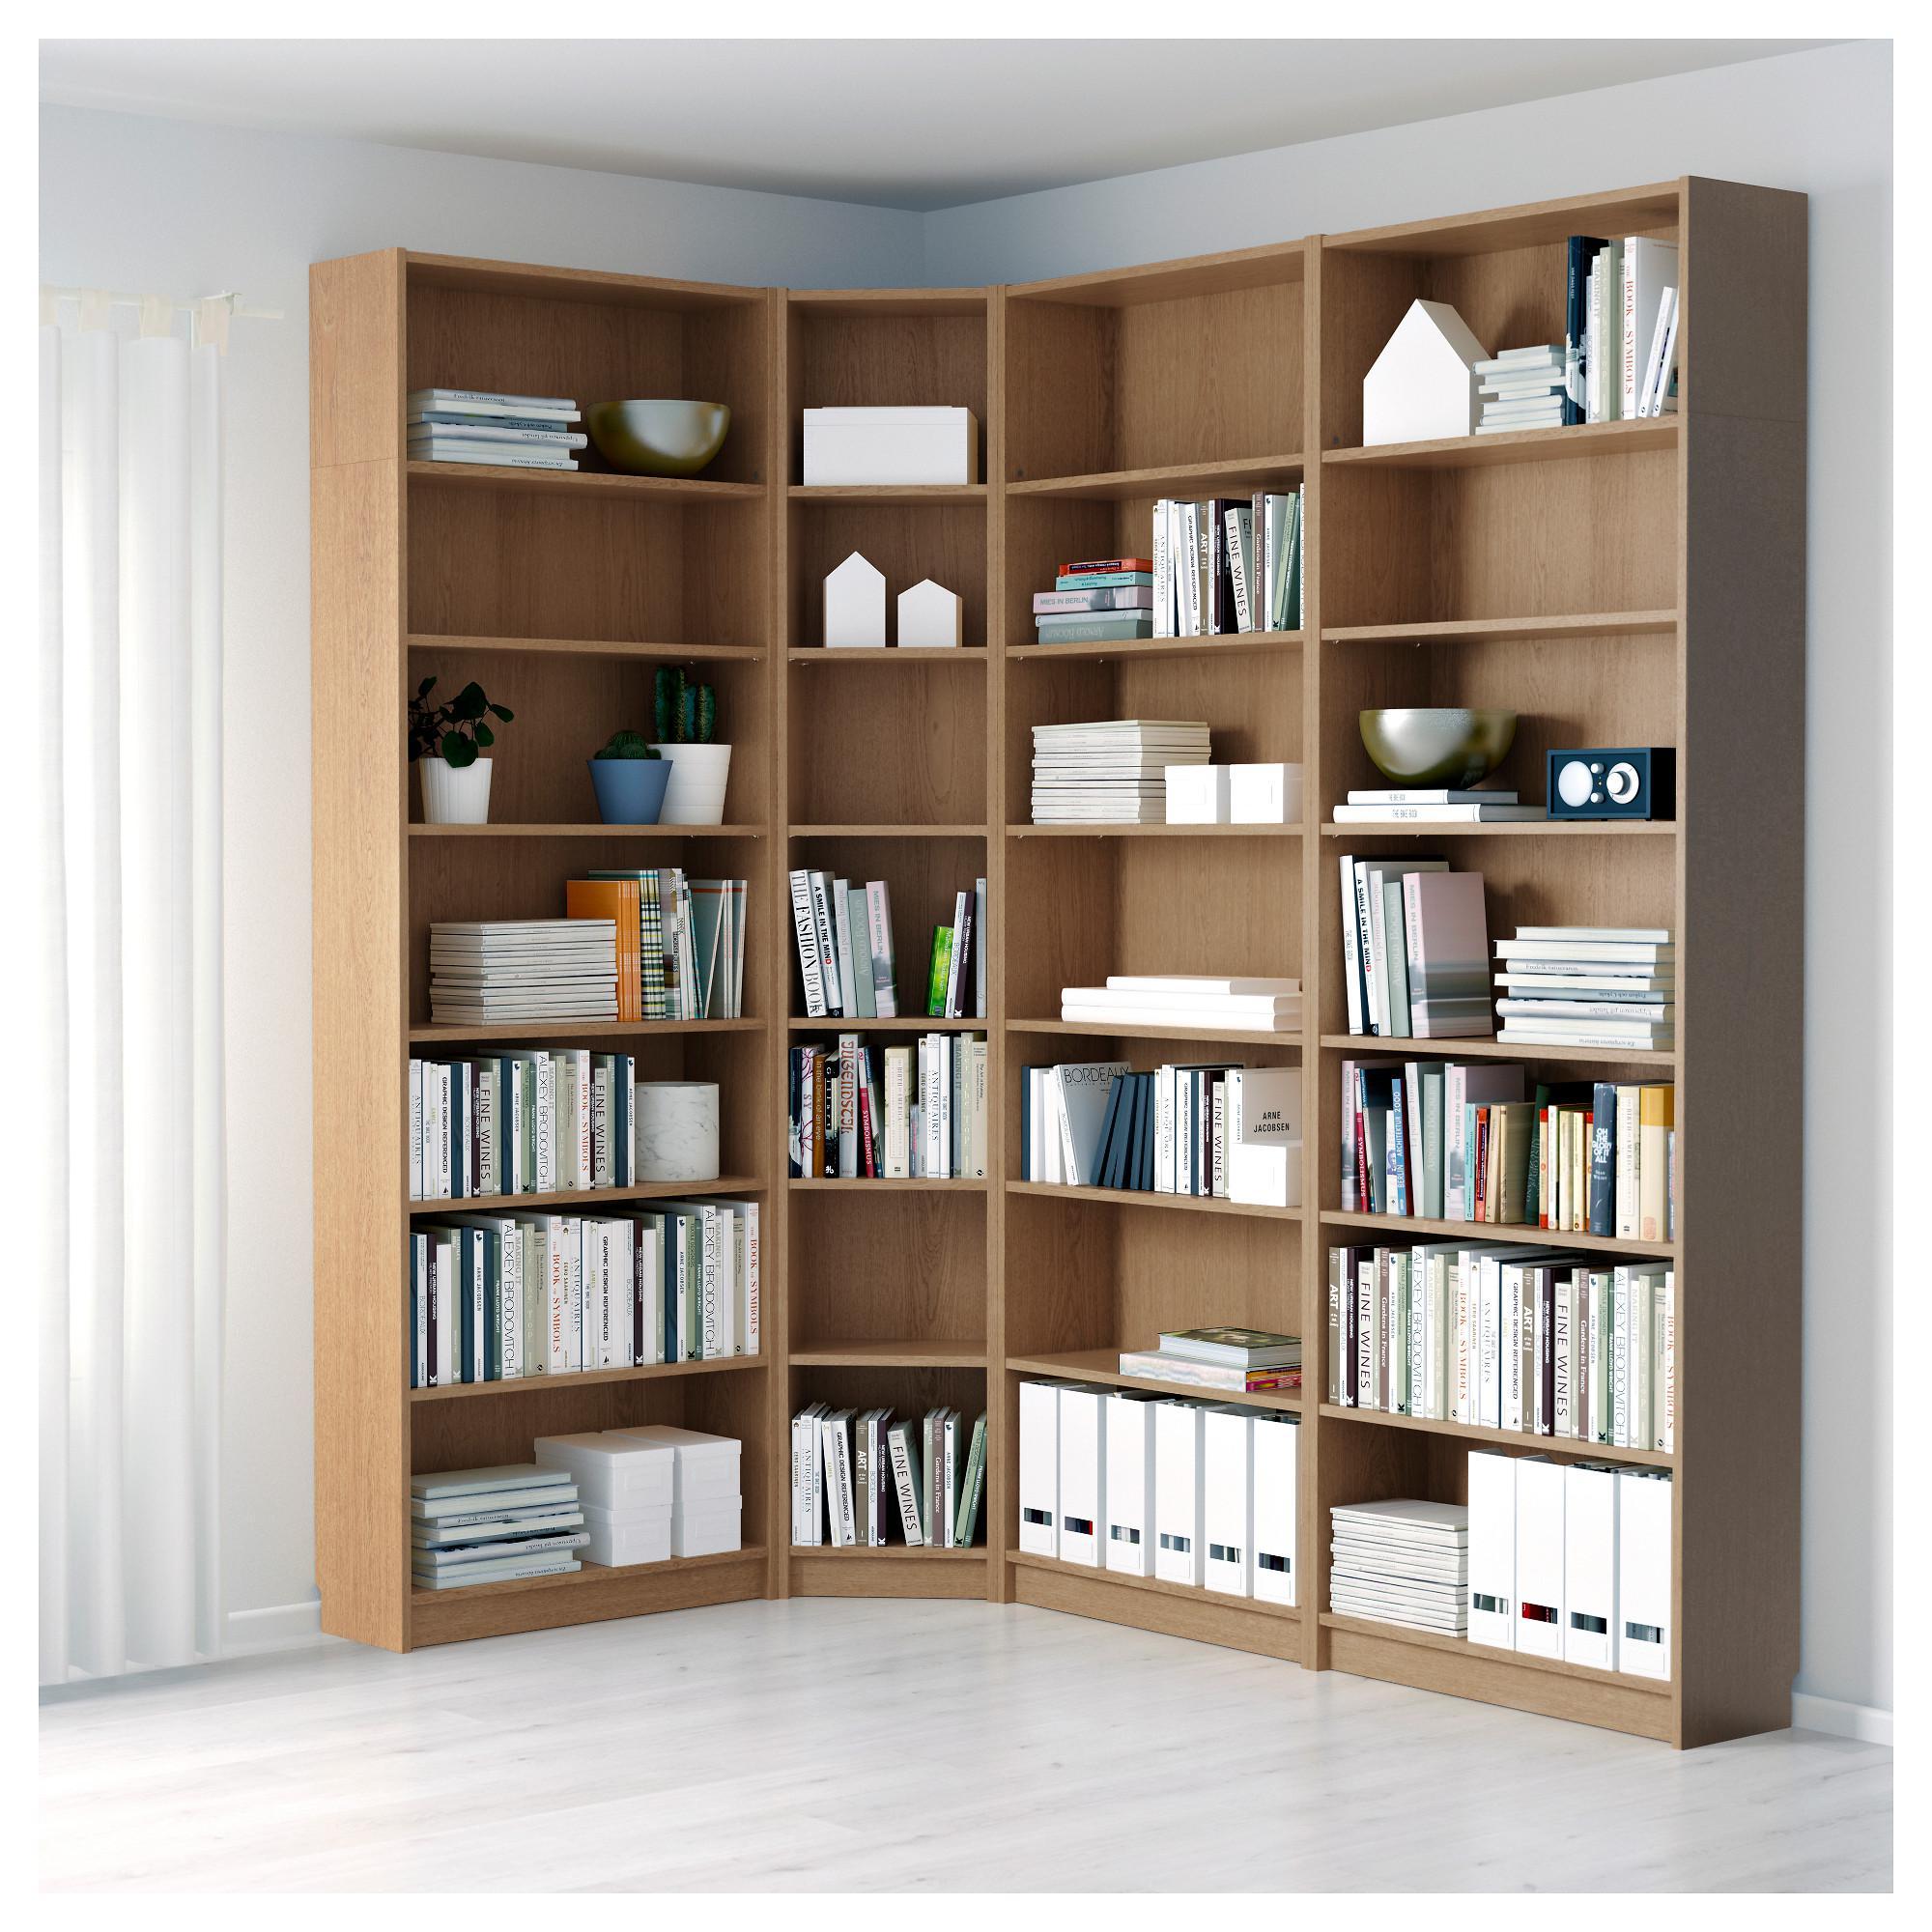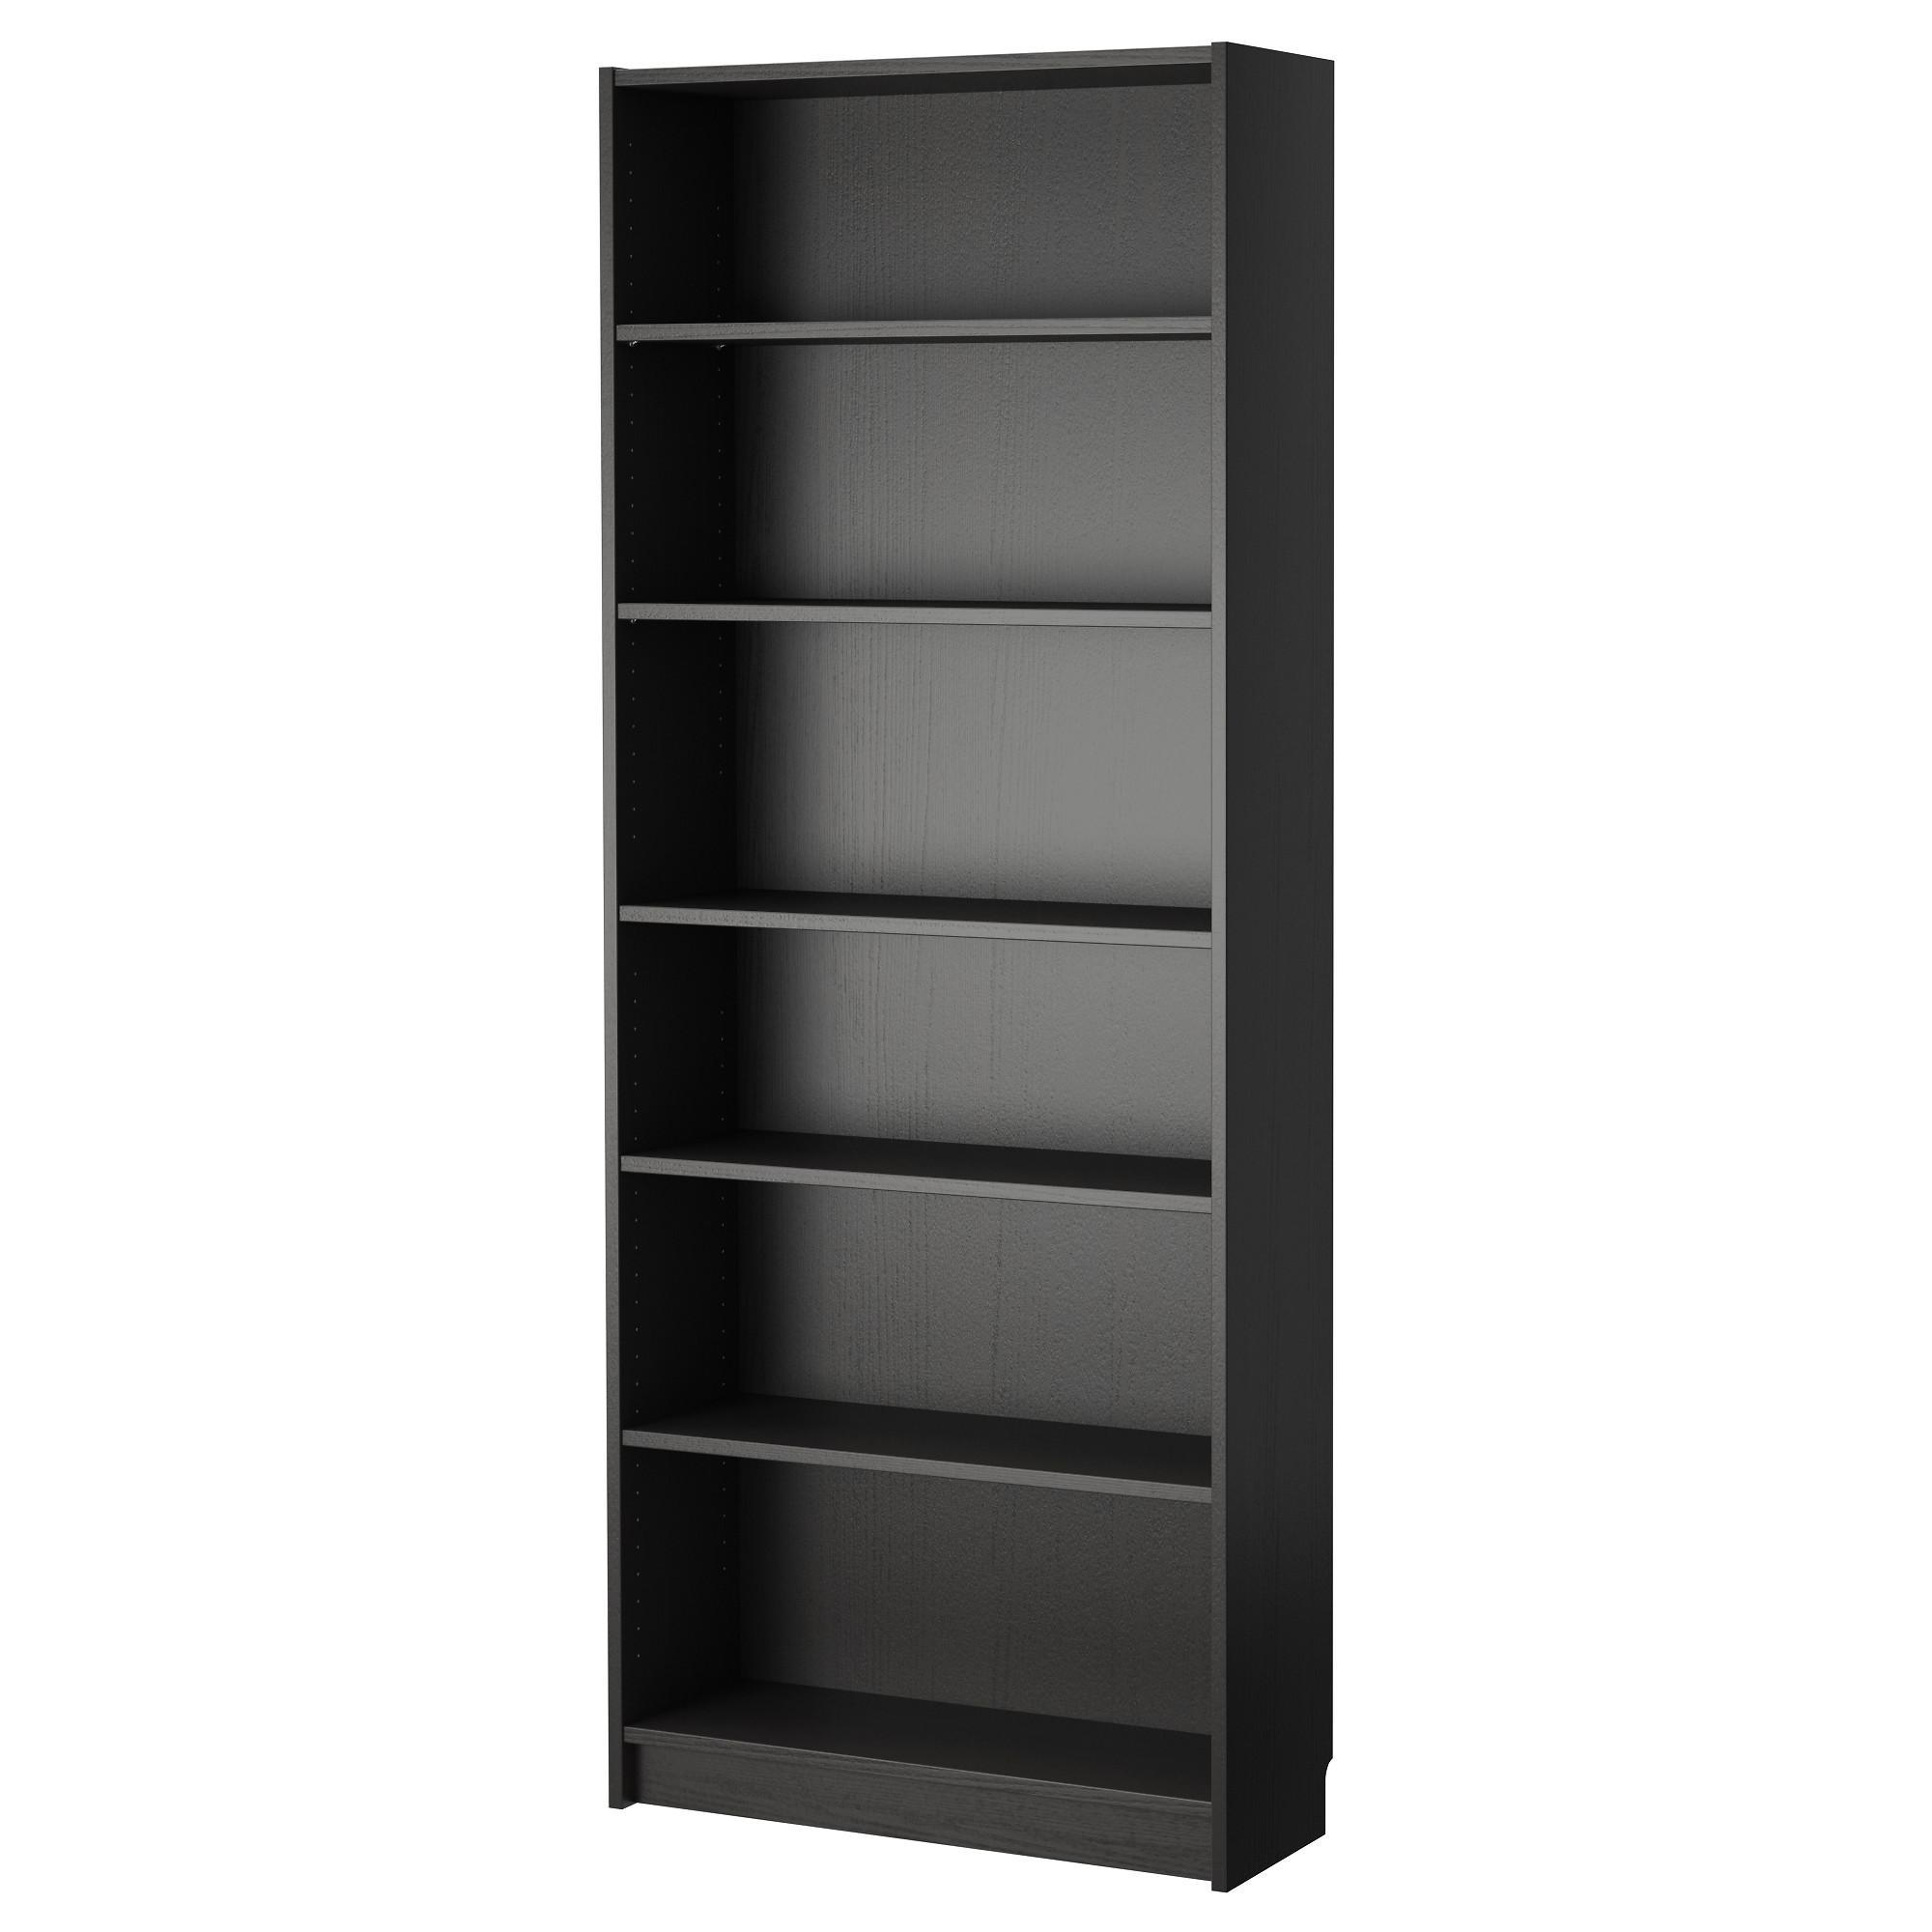The first image is the image on the left, the second image is the image on the right. For the images displayed, is the sentence "At least one of the images shows an empty bookcase." factually correct? Answer yes or no. Yes. 